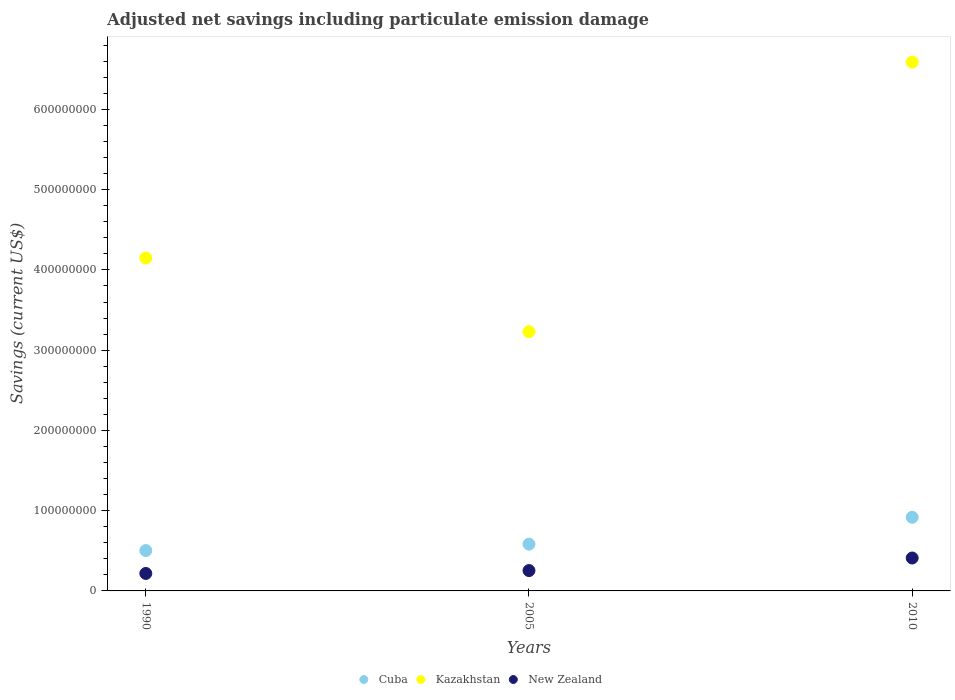Is the number of dotlines equal to the number of legend labels?
Give a very brief answer. Yes. What is the net savings in Kazakhstan in 2010?
Provide a short and direct response. 6.59e+08. Across all years, what is the maximum net savings in New Zealand?
Your answer should be compact. 4.10e+07. Across all years, what is the minimum net savings in New Zealand?
Ensure brevity in your answer.  2.18e+07. In which year was the net savings in New Zealand minimum?
Ensure brevity in your answer.  1990. What is the total net savings in New Zealand in the graph?
Make the answer very short. 8.81e+07. What is the difference between the net savings in New Zealand in 1990 and that in 2010?
Provide a short and direct response. -1.93e+07. What is the difference between the net savings in Kazakhstan in 1990 and the net savings in New Zealand in 2010?
Provide a short and direct response. 3.74e+08. What is the average net savings in Cuba per year?
Your response must be concise. 6.68e+07. In the year 2005, what is the difference between the net savings in Kazakhstan and net savings in New Zealand?
Keep it short and to the point. 2.98e+08. In how many years, is the net savings in Kazakhstan greater than 300000000 US$?
Offer a very short reply. 3. What is the ratio of the net savings in Cuba in 2005 to that in 2010?
Keep it short and to the point. 0.64. What is the difference between the highest and the second highest net savings in New Zealand?
Your answer should be compact. 1.57e+07. What is the difference between the highest and the lowest net savings in New Zealand?
Provide a short and direct response. 1.93e+07. Is the sum of the net savings in Cuba in 1990 and 2010 greater than the maximum net savings in New Zealand across all years?
Make the answer very short. Yes. Is it the case that in every year, the sum of the net savings in Cuba and net savings in Kazakhstan  is greater than the net savings in New Zealand?
Give a very brief answer. Yes. Does the net savings in Cuba monotonically increase over the years?
Your answer should be compact. Yes. How many years are there in the graph?
Keep it short and to the point. 3. What is the difference between two consecutive major ticks on the Y-axis?
Offer a very short reply. 1.00e+08. Are the values on the major ticks of Y-axis written in scientific E-notation?
Ensure brevity in your answer.  No. Does the graph contain any zero values?
Your response must be concise. No. Does the graph contain grids?
Provide a short and direct response. No. What is the title of the graph?
Provide a succinct answer. Adjusted net savings including particulate emission damage. Does "Samoa" appear as one of the legend labels in the graph?
Give a very brief answer. No. What is the label or title of the Y-axis?
Provide a short and direct response. Savings (current US$). What is the Savings (current US$) in Cuba in 1990?
Offer a terse response. 5.03e+07. What is the Savings (current US$) of Kazakhstan in 1990?
Keep it short and to the point. 4.15e+08. What is the Savings (current US$) of New Zealand in 1990?
Ensure brevity in your answer.  2.18e+07. What is the Savings (current US$) in Cuba in 2005?
Your response must be concise. 5.83e+07. What is the Savings (current US$) in Kazakhstan in 2005?
Offer a terse response. 3.23e+08. What is the Savings (current US$) of New Zealand in 2005?
Provide a succinct answer. 2.54e+07. What is the Savings (current US$) in Cuba in 2010?
Offer a terse response. 9.18e+07. What is the Savings (current US$) of Kazakhstan in 2010?
Your answer should be compact. 6.59e+08. What is the Savings (current US$) in New Zealand in 2010?
Offer a very short reply. 4.10e+07. Across all years, what is the maximum Savings (current US$) of Cuba?
Offer a very short reply. 9.18e+07. Across all years, what is the maximum Savings (current US$) of Kazakhstan?
Your response must be concise. 6.59e+08. Across all years, what is the maximum Savings (current US$) of New Zealand?
Provide a succinct answer. 4.10e+07. Across all years, what is the minimum Savings (current US$) in Cuba?
Offer a very short reply. 5.03e+07. Across all years, what is the minimum Savings (current US$) of Kazakhstan?
Provide a succinct answer. 3.23e+08. Across all years, what is the minimum Savings (current US$) of New Zealand?
Offer a terse response. 2.18e+07. What is the total Savings (current US$) in Cuba in the graph?
Your answer should be very brief. 2.00e+08. What is the total Savings (current US$) in Kazakhstan in the graph?
Keep it short and to the point. 1.40e+09. What is the total Savings (current US$) in New Zealand in the graph?
Give a very brief answer. 8.81e+07. What is the difference between the Savings (current US$) in Cuba in 1990 and that in 2005?
Provide a short and direct response. -7.99e+06. What is the difference between the Savings (current US$) of Kazakhstan in 1990 and that in 2005?
Give a very brief answer. 9.18e+07. What is the difference between the Savings (current US$) of New Zealand in 1990 and that in 2005?
Keep it short and to the point. -3.60e+06. What is the difference between the Savings (current US$) in Cuba in 1990 and that in 2010?
Provide a succinct answer. -4.15e+07. What is the difference between the Savings (current US$) in Kazakhstan in 1990 and that in 2010?
Your response must be concise. -2.44e+08. What is the difference between the Savings (current US$) in New Zealand in 1990 and that in 2010?
Offer a very short reply. -1.93e+07. What is the difference between the Savings (current US$) of Cuba in 2005 and that in 2010?
Provide a short and direct response. -3.35e+07. What is the difference between the Savings (current US$) of Kazakhstan in 2005 and that in 2010?
Your response must be concise. -3.36e+08. What is the difference between the Savings (current US$) in New Zealand in 2005 and that in 2010?
Your response must be concise. -1.57e+07. What is the difference between the Savings (current US$) in Cuba in 1990 and the Savings (current US$) in Kazakhstan in 2005?
Your response must be concise. -2.73e+08. What is the difference between the Savings (current US$) of Cuba in 1990 and the Savings (current US$) of New Zealand in 2005?
Your answer should be compact. 2.49e+07. What is the difference between the Savings (current US$) in Kazakhstan in 1990 and the Savings (current US$) in New Zealand in 2005?
Your response must be concise. 3.90e+08. What is the difference between the Savings (current US$) in Cuba in 1990 and the Savings (current US$) in Kazakhstan in 2010?
Offer a terse response. -6.09e+08. What is the difference between the Savings (current US$) of Cuba in 1990 and the Savings (current US$) of New Zealand in 2010?
Ensure brevity in your answer.  9.28e+06. What is the difference between the Savings (current US$) of Kazakhstan in 1990 and the Savings (current US$) of New Zealand in 2010?
Make the answer very short. 3.74e+08. What is the difference between the Savings (current US$) in Cuba in 2005 and the Savings (current US$) in Kazakhstan in 2010?
Provide a short and direct response. -6.01e+08. What is the difference between the Savings (current US$) of Cuba in 2005 and the Savings (current US$) of New Zealand in 2010?
Offer a terse response. 1.73e+07. What is the difference between the Savings (current US$) in Kazakhstan in 2005 and the Savings (current US$) in New Zealand in 2010?
Make the answer very short. 2.82e+08. What is the average Savings (current US$) in Cuba per year?
Your answer should be very brief. 6.68e+07. What is the average Savings (current US$) of Kazakhstan per year?
Your answer should be very brief. 4.66e+08. What is the average Savings (current US$) of New Zealand per year?
Make the answer very short. 2.94e+07. In the year 1990, what is the difference between the Savings (current US$) of Cuba and Savings (current US$) of Kazakhstan?
Make the answer very short. -3.65e+08. In the year 1990, what is the difference between the Savings (current US$) in Cuba and Savings (current US$) in New Zealand?
Keep it short and to the point. 2.85e+07. In the year 1990, what is the difference between the Savings (current US$) in Kazakhstan and Savings (current US$) in New Zealand?
Offer a very short reply. 3.93e+08. In the year 2005, what is the difference between the Savings (current US$) in Cuba and Savings (current US$) in Kazakhstan?
Your response must be concise. -2.65e+08. In the year 2005, what is the difference between the Savings (current US$) of Cuba and Savings (current US$) of New Zealand?
Provide a short and direct response. 3.29e+07. In the year 2005, what is the difference between the Savings (current US$) in Kazakhstan and Savings (current US$) in New Zealand?
Offer a terse response. 2.98e+08. In the year 2010, what is the difference between the Savings (current US$) in Cuba and Savings (current US$) in Kazakhstan?
Offer a very short reply. -5.67e+08. In the year 2010, what is the difference between the Savings (current US$) of Cuba and Savings (current US$) of New Zealand?
Ensure brevity in your answer.  5.08e+07. In the year 2010, what is the difference between the Savings (current US$) of Kazakhstan and Savings (current US$) of New Zealand?
Your response must be concise. 6.18e+08. What is the ratio of the Savings (current US$) of Cuba in 1990 to that in 2005?
Your answer should be very brief. 0.86. What is the ratio of the Savings (current US$) in Kazakhstan in 1990 to that in 2005?
Offer a very short reply. 1.28. What is the ratio of the Savings (current US$) of New Zealand in 1990 to that in 2005?
Offer a terse response. 0.86. What is the ratio of the Savings (current US$) of Cuba in 1990 to that in 2010?
Your answer should be very brief. 0.55. What is the ratio of the Savings (current US$) in Kazakhstan in 1990 to that in 2010?
Keep it short and to the point. 0.63. What is the ratio of the Savings (current US$) in New Zealand in 1990 to that in 2010?
Your answer should be very brief. 0.53. What is the ratio of the Savings (current US$) of Cuba in 2005 to that in 2010?
Provide a short and direct response. 0.64. What is the ratio of the Savings (current US$) of Kazakhstan in 2005 to that in 2010?
Give a very brief answer. 0.49. What is the ratio of the Savings (current US$) in New Zealand in 2005 to that in 2010?
Offer a very short reply. 0.62. What is the difference between the highest and the second highest Savings (current US$) in Cuba?
Give a very brief answer. 3.35e+07. What is the difference between the highest and the second highest Savings (current US$) of Kazakhstan?
Keep it short and to the point. 2.44e+08. What is the difference between the highest and the second highest Savings (current US$) of New Zealand?
Make the answer very short. 1.57e+07. What is the difference between the highest and the lowest Savings (current US$) in Cuba?
Your answer should be compact. 4.15e+07. What is the difference between the highest and the lowest Savings (current US$) in Kazakhstan?
Your answer should be compact. 3.36e+08. What is the difference between the highest and the lowest Savings (current US$) of New Zealand?
Your answer should be very brief. 1.93e+07. 